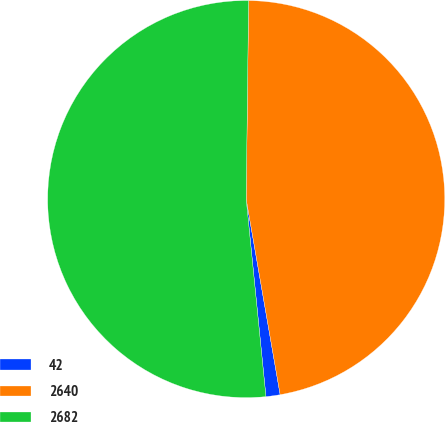Convert chart. <chart><loc_0><loc_0><loc_500><loc_500><pie_chart><fcel>42<fcel>2640<fcel>2682<nl><fcel>1.15%<fcel>47.07%<fcel>51.78%<nl></chart> 